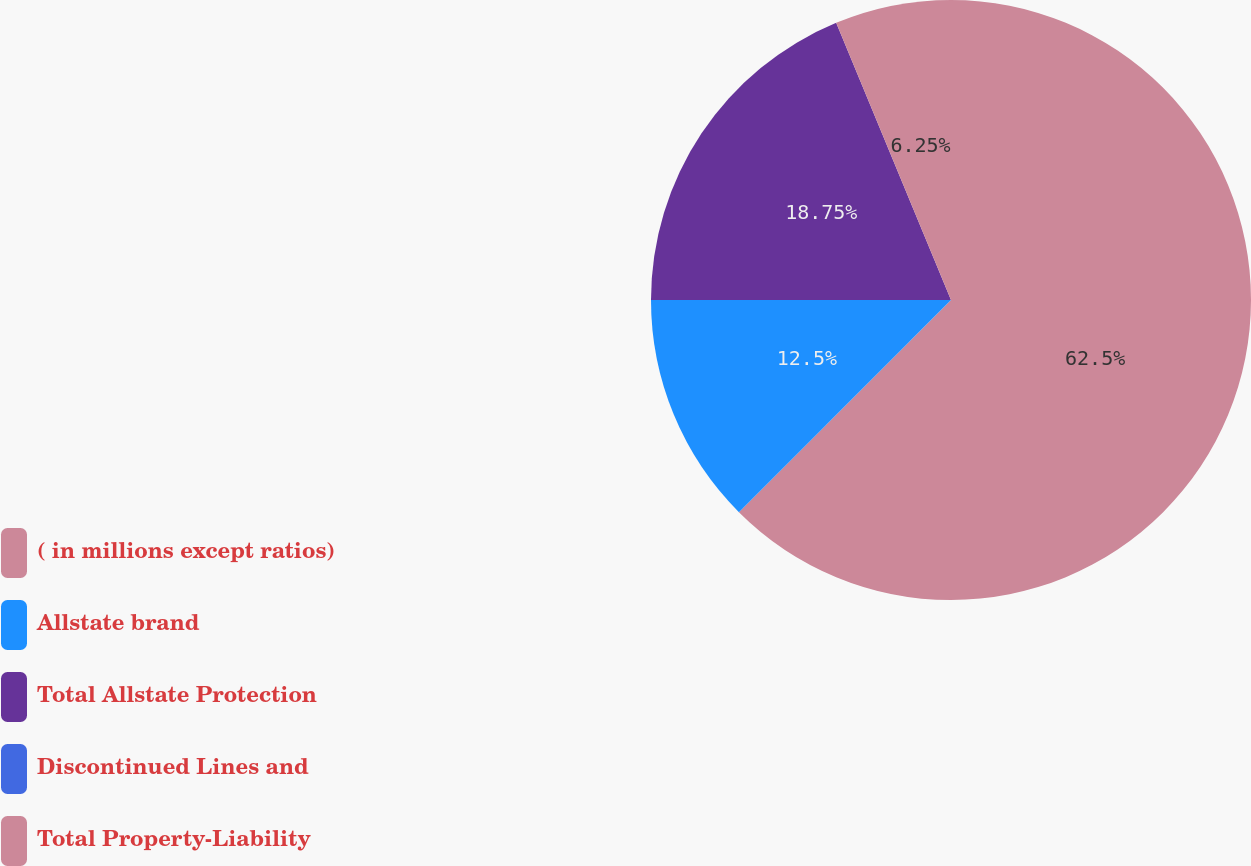Convert chart to OTSL. <chart><loc_0><loc_0><loc_500><loc_500><pie_chart><fcel>( in millions except ratios)<fcel>Allstate brand<fcel>Total Allstate Protection<fcel>Discontinued Lines and<fcel>Total Property-Liability<nl><fcel>62.49%<fcel>12.5%<fcel>18.75%<fcel>0.0%<fcel>6.25%<nl></chart> 